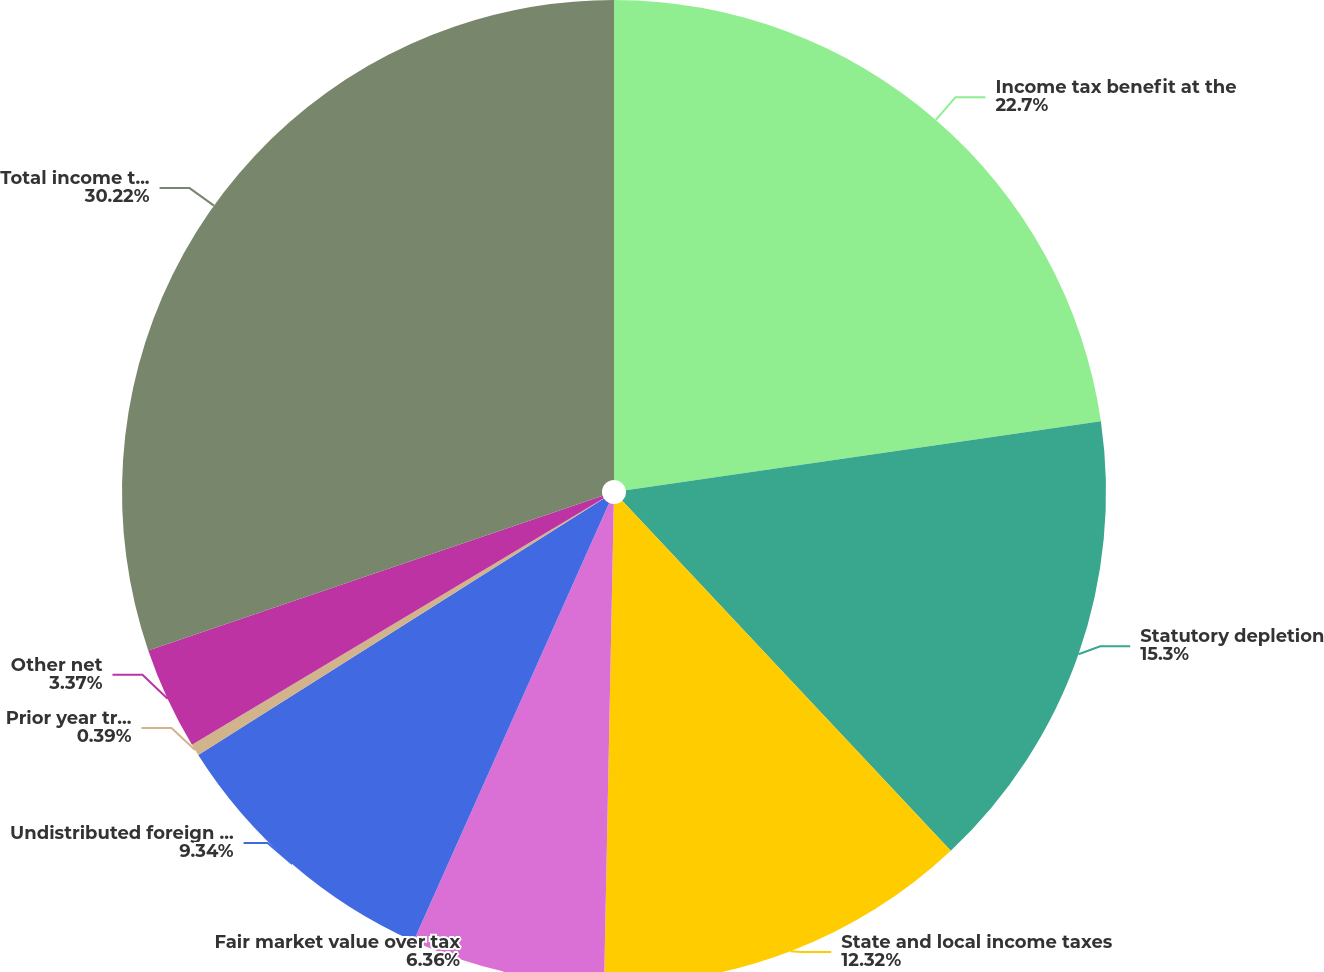<chart> <loc_0><loc_0><loc_500><loc_500><pie_chart><fcel>Income tax benefit at the<fcel>Statutory depletion<fcel>State and local income taxes<fcel>Fair market value over tax<fcel>Undistributed foreign earnings<fcel>Prior year true up adjustments<fcel>Other net<fcel>Total income tax benefit<nl><fcel>22.7%<fcel>15.3%<fcel>12.32%<fcel>6.36%<fcel>9.34%<fcel>0.39%<fcel>3.37%<fcel>30.22%<nl></chart> 